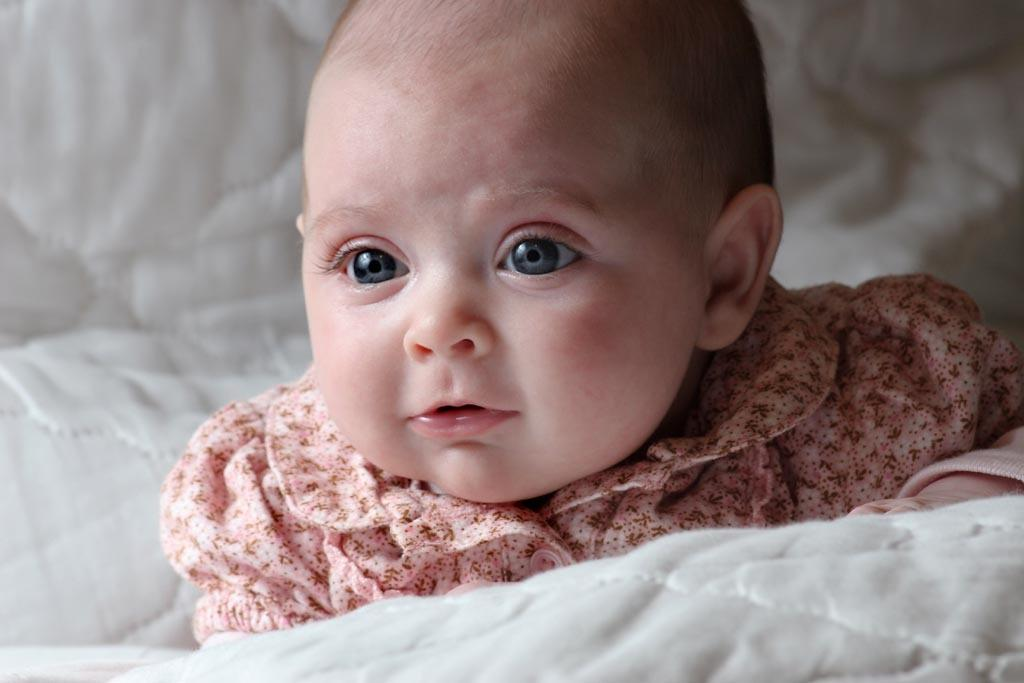What is located in the foreground of the image? There is a blanket in the foreground of the image. What can be seen behind the blanket in the image? There is a baby behind the blanket in the image. What type of giraffe can be seen holding a brush in the image? There is no giraffe or brush present in the image. How many fingers can be seen on the baby's hand in the image? The image does not show the baby's hand, so it cannot be determined how many fingers are visible. 